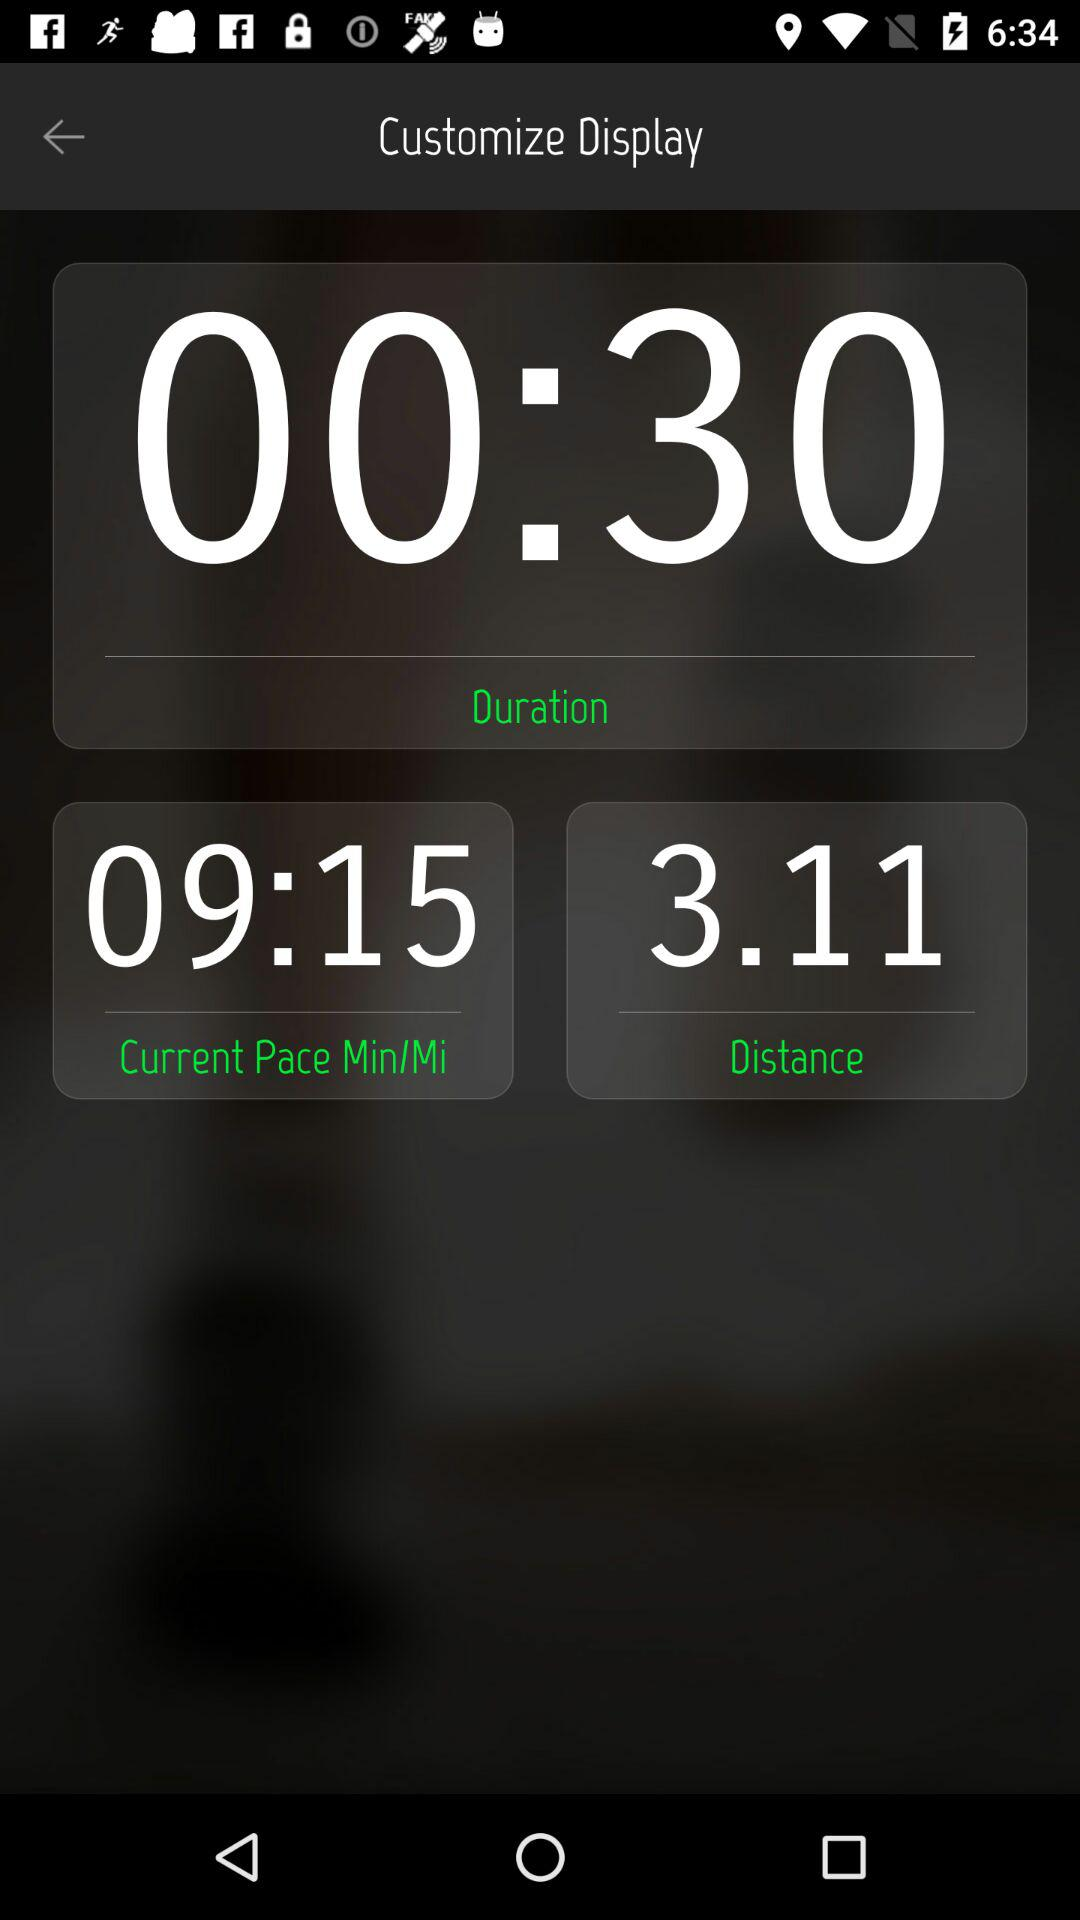What is the current pace? The current pace is 9 minutes 15 seconds per mile. 